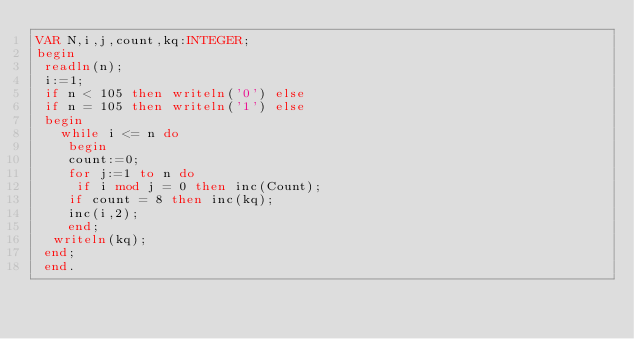<code> <loc_0><loc_0><loc_500><loc_500><_Pascal_>VAR N,i,j,count,kq:INTEGER;
begin
 readln(n);
 i:=1;
 if n < 105 then writeln('0') else
 if n = 105 then writeln('1') else 
 begin
   while i <= n do 
    begin
    count:=0;
    for j:=1 to n do 
     if i mod j = 0 then inc(Count);
    if count = 8 then inc(kq);
    inc(i,2);
    end;
  writeln(kq);
 end;
 end.</code> 